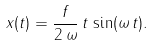Convert formula to latex. <formula><loc_0><loc_0><loc_500><loc_500>x ( t ) = \frac { f } { 2 \, \omega } \, t \, \sin ( \omega \, t ) .</formula> 